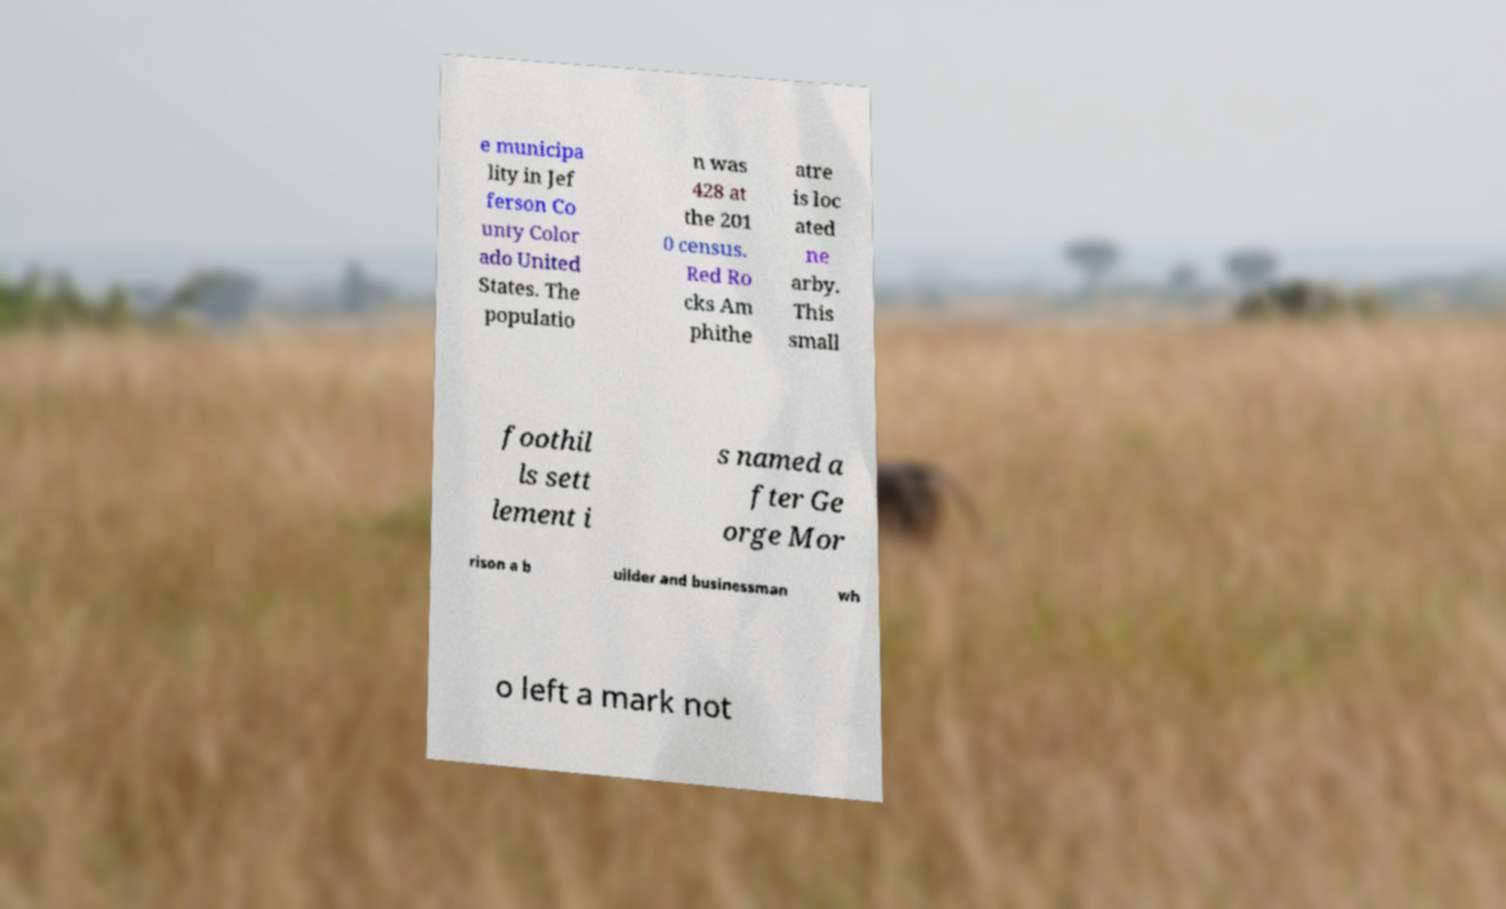Can you read and provide the text displayed in the image?This photo seems to have some interesting text. Can you extract and type it out for me? e municipa lity in Jef ferson Co unty Color ado United States. The populatio n was 428 at the 201 0 census. Red Ro cks Am phithe atre is loc ated ne arby. This small foothil ls sett lement i s named a fter Ge orge Mor rison a b uilder and businessman wh o left a mark not 